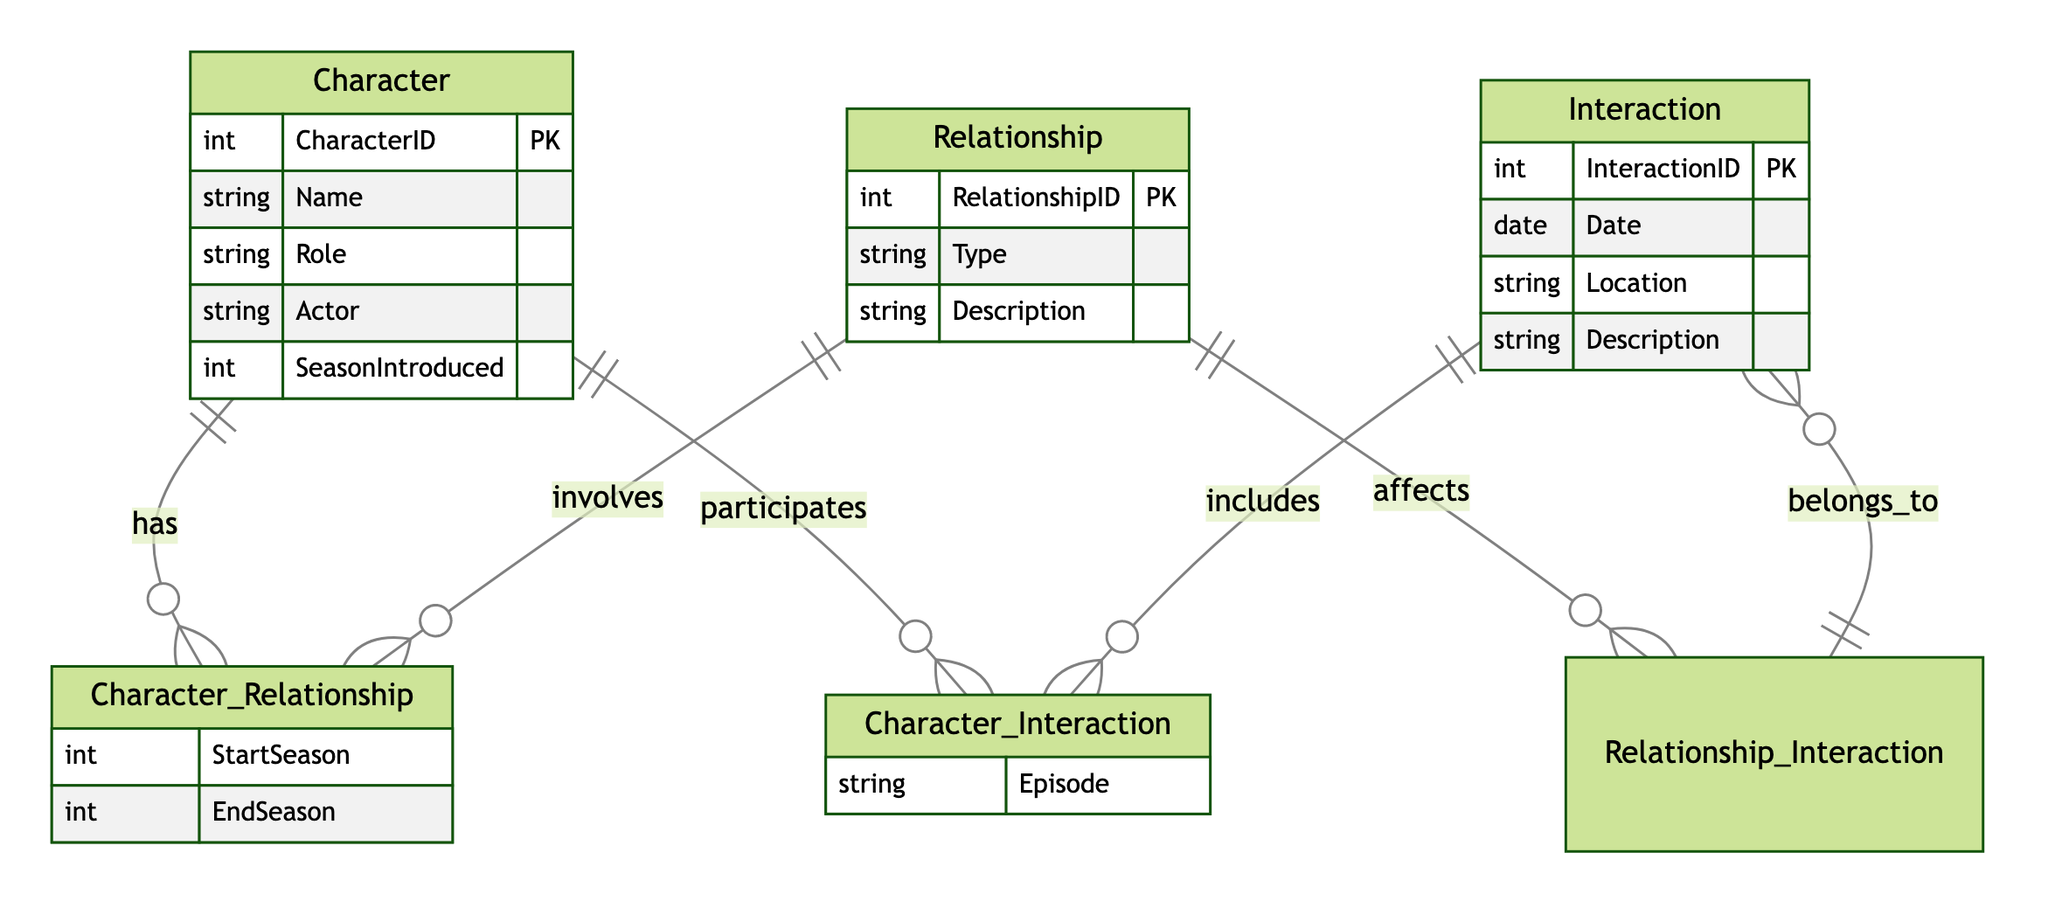What are the main entities in the diagram? The main entities are listed as Character, Relationship, and Interaction. These can be identified by looking at the entity section of the diagram where three distinct boxes are drawn for each entity.
Answer: Character, Relationship, Interaction How many attributes does the Character entity have? The Character entity contains five attributes: CharacterID, Name, Role, Actor, and SeasonIntroduced. This information can be seen in the attributes listed under the Character entity box.
Answer: Five What does the Character_Relationship relationship include? The Character_Relationship includes attributes StartSeason and EndSeason, which can be seen listed under that relationship section.
Answer: StartSeason, EndSeason In how many interactions can a character participate? A character can participate in multiple interactions as indicated by the many-to-many relationship between Character and Interaction, shown by the 'o{' symbol next to both entities.
Answer: Multiple What attribute describes the type of relationship? The attribute that describes the type of relationship is 'Type', which appears in the attributes section of the Relationship entity.
Answer: Type Which entity has 'Actor' as an attribute? The 'Actor' attribute is part of the Character entity, as seen in the attributes listed specifically under the Character section.
Answer: Character 